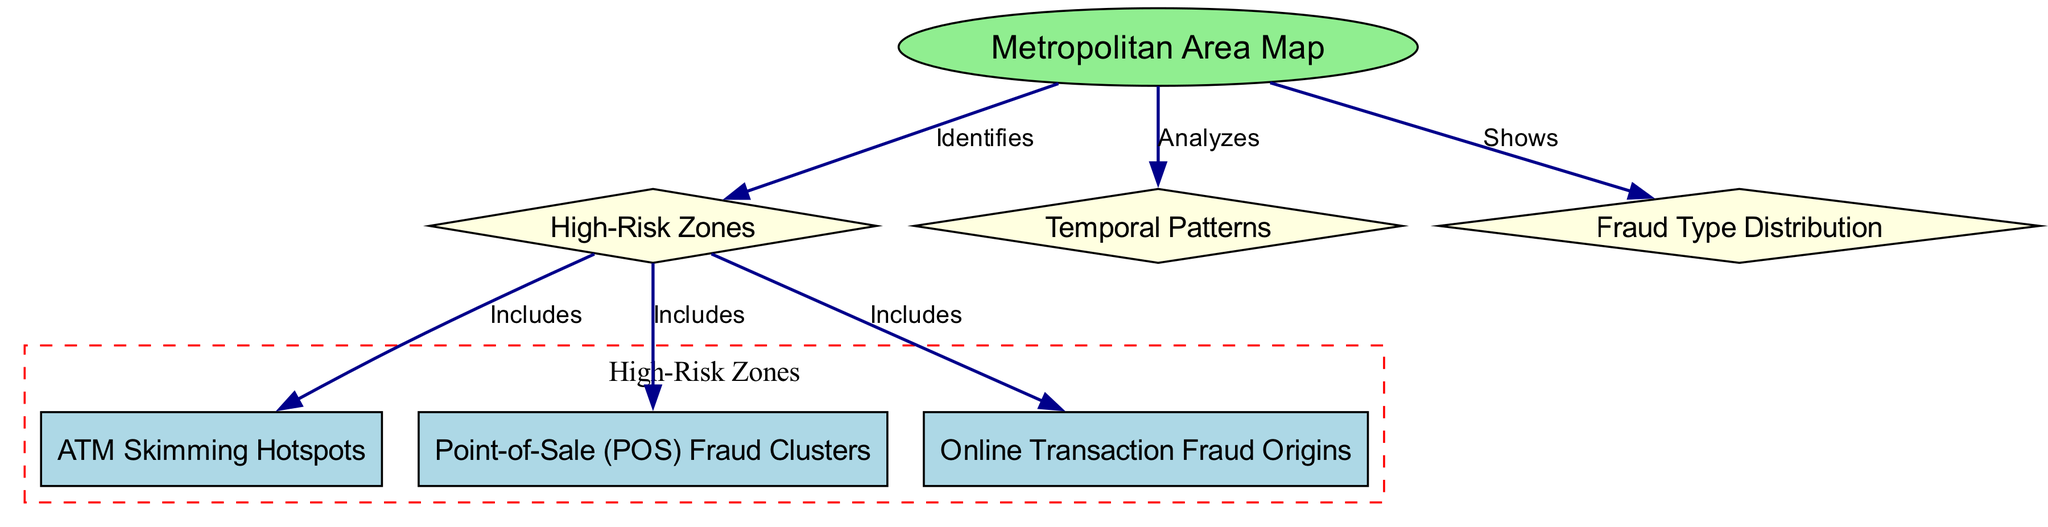What is the main subject of the diagram? The main subject is the "Geospatial Analysis of Credit Card Fraud," as indicated by the title and central node.
Answer: Geospatial Analysis of Credit Card Fraud How many total nodes are in the diagram? By counting the nodes listed in the data, there are a total of seven nodes.
Answer: 7 What does the "Metropolitan Area Map" node analyze? The "Metropolitan Area Map" node analyzes "Temporal Patterns" and shows "Fraud Type Distribution," as indicated by the edges leading to these nodes.
Answer: Temporal Patterns, Fraud Type Distribution Which type of fraud is included in the "High-Risk Zones"? Among the fraudes indicated in the "High-Risk Zones," "ATM Skimming Hotspots," "Point-of-Sale (POS) Fraud Clusters," and "Online Transaction Fraud Origins" are included, as detailed by the edges.
Answer: ATM Skimming Hotspots, Point-of-Sale (POS) Fraud Clusters, Online Transaction Fraud Origins How are "High-Risk Zones" defined in the diagram? "High-Risk Zones" are defined by the edges originating from the "Metropolitan Area Map" node, which identifies and includes the related fraud hotspots and clusters.
Answer: Identifies and Includes Which node has the most connections, and how many are there? The "High-Risk Zones" node has three connections to "ATM Skimming Hotspots," "Point-of-Sale (POS) Fraud Clusters," and "Online Transaction Fraud Origins," making it the most connected node.
Answer: 3 What type of information does the "Fraud Type Distribution" node provide? The "Fraud Type Distribution" node shows the distribution of different types of fraud incidents across the metropolitan area.
Answer: Distribution of fraud types Which concept does the edge from "Metropolitan Area Map" to "High-Risk Zones" represent? This edge represents the concept of identification, showing that the map identifies areas that are high-risk for credit card fraud.
Answer: Identifies 